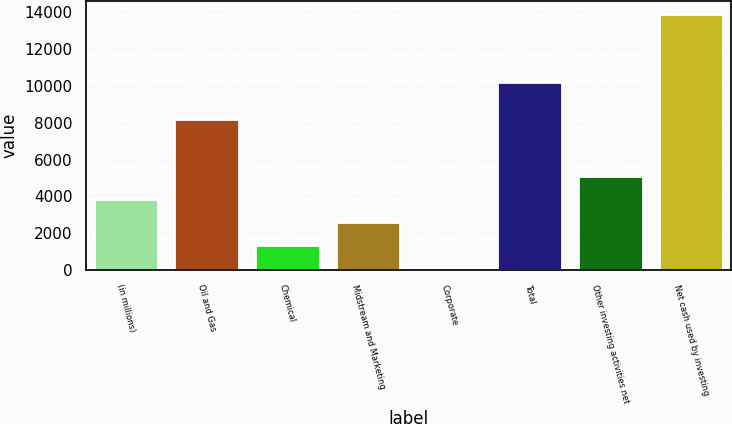Convert chart. <chart><loc_0><loc_0><loc_500><loc_500><bar_chart><fcel>(in millions)<fcel>Oil and Gas<fcel>Chemical<fcel>Midstream and Marketing<fcel>Corporate<fcel>Total<fcel>Other investing activities net<fcel>Net cash used by investing<nl><fcel>3860.2<fcel>8220<fcel>1347.4<fcel>2603.8<fcel>91<fcel>10226<fcel>5116.6<fcel>13911.4<nl></chart> 